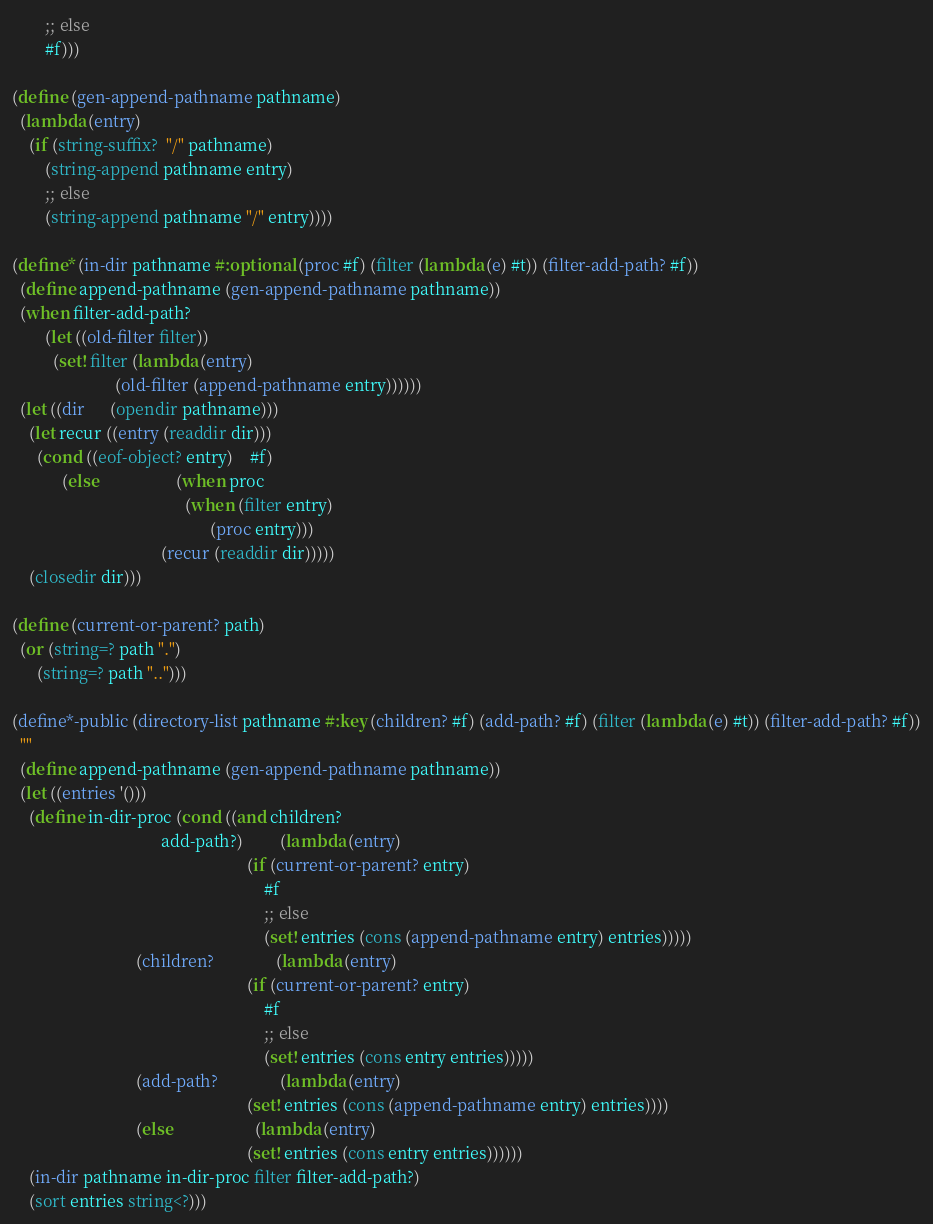Convert code to text. <code><loc_0><loc_0><loc_500><loc_500><_Scheme_>        ;; else
        #f)))

(define (gen-append-pathname pathname)
  (lambda (entry)
    (if (string-suffix?  "/" pathname)
        (string-append pathname entry)
        ;; else
        (string-append pathname "/" entry))))

(define* (in-dir pathname #:optional (proc #f) (filter (lambda (e) #t)) (filter-add-path? #f))
  (define append-pathname (gen-append-pathname pathname))
  (when filter-add-path?
        (let ((old-filter filter))
          (set! filter (lambda (entry)
                         (old-filter (append-pathname entry))))))
  (let ((dir      (opendir pathname)))
    (let recur ((entry (readdir dir)))
      (cond ((eof-object? entry)    #f)
            (else                   (when proc
                                          (when (filter entry)
                                                (proc entry)))
                                    (recur (readdir dir)))))
    (closedir dir)))

(define (current-or-parent? path)
  (or (string=? path ".")
      (string=? path "..")))

(define*-public (directory-list pathname #:key (children? #f) (add-path? #f) (filter (lambda (e) #t)) (filter-add-path? #f))
  ""
  (define append-pathname (gen-append-pathname pathname))
  (let ((entries '()))
    (define in-dir-proc (cond ((and children?
                                    add-path?)         (lambda (entry)
                                                         (if (current-or-parent? entry)
                                                             #f
                                                             ;; else
                                                             (set! entries (cons (append-pathname entry) entries)))))
                              (children?               (lambda (entry)
                                                         (if (current-or-parent? entry)
                                                             #f
                                                             ;; else
                                                             (set! entries (cons entry entries)))))
                              (add-path?               (lambda (entry)
                                                         (set! entries (cons (append-pathname entry) entries))))
                              (else                    (lambda (entry)
                                                         (set! entries (cons entry entries))))))
    (in-dir pathname in-dir-proc filter filter-add-path?)
    (sort entries string<?)))
</code> 